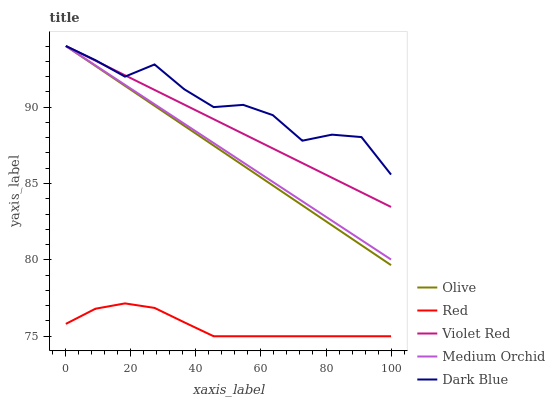Does Violet Red have the minimum area under the curve?
Answer yes or no. No. Does Violet Red have the maximum area under the curve?
Answer yes or no. No. Is Violet Red the smoothest?
Answer yes or no. No. Is Violet Red the roughest?
Answer yes or no. No. Does Violet Red have the lowest value?
Answer yes or no. No. Does Red have the highest value?
Answer yes or no. No. Is Red less than Medium Orchid?
Answer yes or no. Yes. Is Olive greater than Red?
Answer yes or no. Yes. Does Red intersect Medium Orchid?
Answer yes or no. No. 